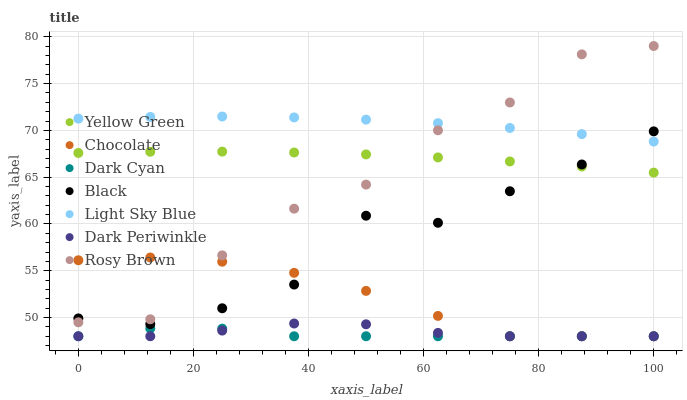Does Dark Cyan have the minimum area under the curve?
Answer yes or no. Yes. Does Light Sky Blue have the maximum area under the curve?
Answer yes or no. Yes. Does Rosy Brown have the minimum area under the curve?
Answer yes or no. No. Does Rosy Brown have the maximum area under the curve?
Answer yes or no. No. Is Yellow Green the smoothest?
Answer yes or no. Yes. Is Rosy Brown the roughest?
Answer yes or no. Yes. Is Chocolate the smoothest?
Answer yes or no. No. Is Chocolate the roughest?
Answer yes or no. No. Does Chocolate have the lowest value?
Answer yes or no. Yes. Does Rosy Brown have the lowest value?
Answer yes or no. No. Does Rosy Brown have the highest value?
Answer yes or no. Yes. Does Chocolate have the highest value?
Answer yes or no. No. Is Chocolate less than Yellow Green?
Answer yes or no. Yes. Is Black greater than Dark Periwinkle?
Answer yes or no. Yes. Does Rosy Brown intersect Yellow Green?
Answer yes or no. Yes. Is Rosy Brown less than Yellow Green?
Answer yes or no. No. Is Rosy Brown greater than Yellow Green?
Answer yes or no. No. Does Chocolate intersect Yellow Green?
Answer yes or no. No. 